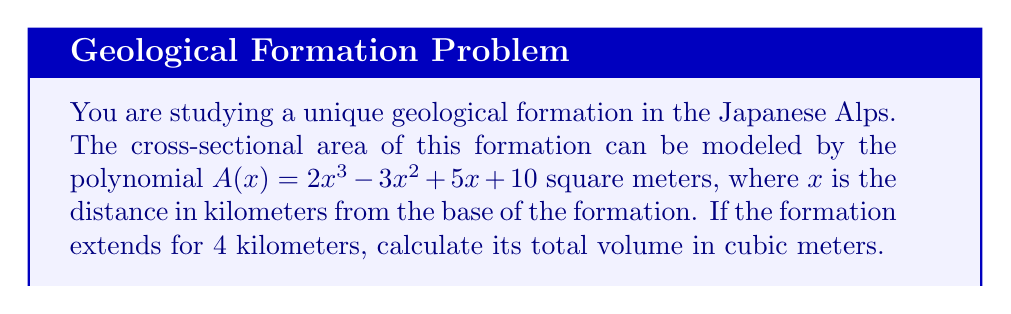Could you help me with this problem? To solve this problem, we need to integrate the cross-sectional area function over the given distance. This will give us the volume of the formation.

1) The volume of a solid with a variable cross-sectional area is given by the integral:

   $$V = \int_{0}^{4} A(x) dx$$

2) Substituting our polynomial for $A(x)$:

   $$V = \int_{0}^{4} (2x^3 - 3x^2 + 5x + 10) dx$$

3) Integrate each term:

   $$V = \left[\frac{1}{2}x^4 - x^3 + \frac{5}{2}x^2 + 10x\right]_{0}^{4}$$

4) Evaluate the integral:

   $$V = \left(\frac{1}{2}(4^4) - (4^3) + \frac{5}{2}(4^2) + 10(4)\right) - \left(\frac{1}{2}(0^4) - (0^3) + \frac{5}{2}(0^2) + 10(0)\right)$$

5) Simplify:

   $$V = (128 - 64 + 40 + 40) - (0)$$
   $$V = 144$$

6) The result is in km³, so we need to convert to m³:

   $$V = 144 \times 1,000,000 = 144,000,000 \text{ m}^3$$
Answer: The total volume of the geological formation is 144,000,000 m³. 